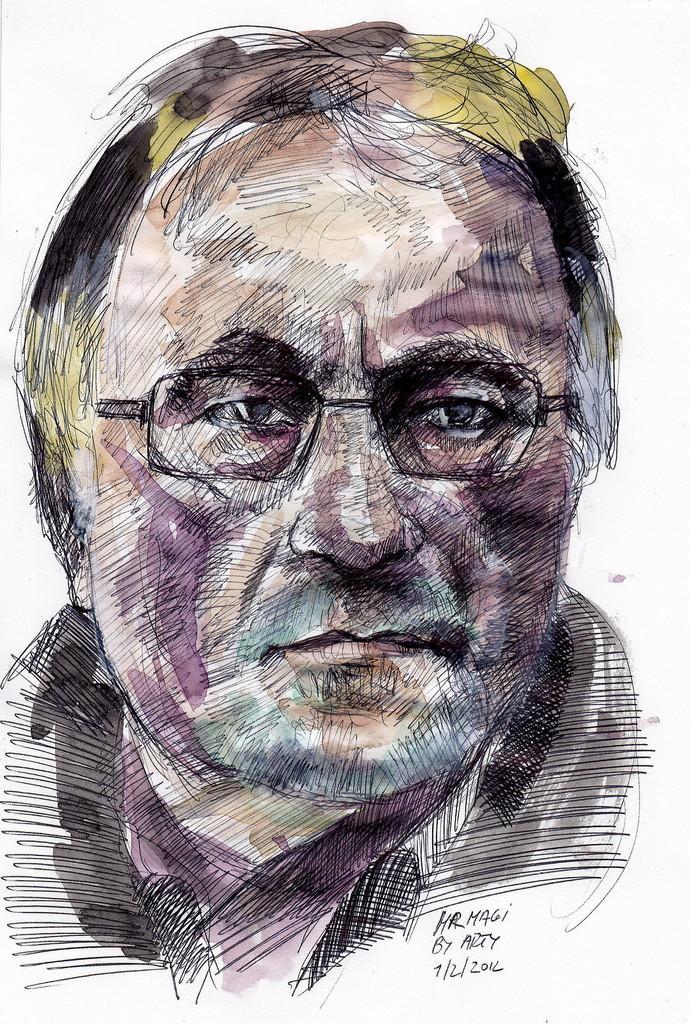In one or two sentences, can you explain what this image depicts? In this picture we can see a colorful sketch of a person wearing glasses and at the bottom right corner we can see some text written on it. 